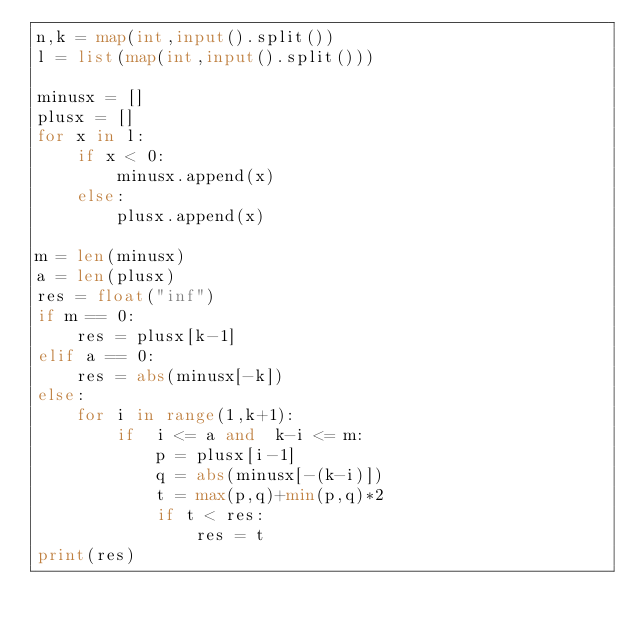<code> <loc_0><loc_0><loc_500><loc_500><_Python_>n,k = map(int,input().split())
l = list(map(int,input().split()))

minusx = []
plusx = []
for x in l:
    if x < 0:
        minusx.append(x)
    else:
        plusx.append(x)

m = len(minusx)
a = len(plusx)
res = float("inf")
if m == 0:
    res = plusx[k-1]
elif a == 0:
    res = abs(minusx[-k])
else:
    for i in range(1,k+1):
        if  i <= a and  k-i <= m:
            p = plusx[i-1]
            q = abs(minusx[-(k-i)])
            t = max(p,q)+min(p,q)*2
            if t < res:
                res = t
print(res)</code> 